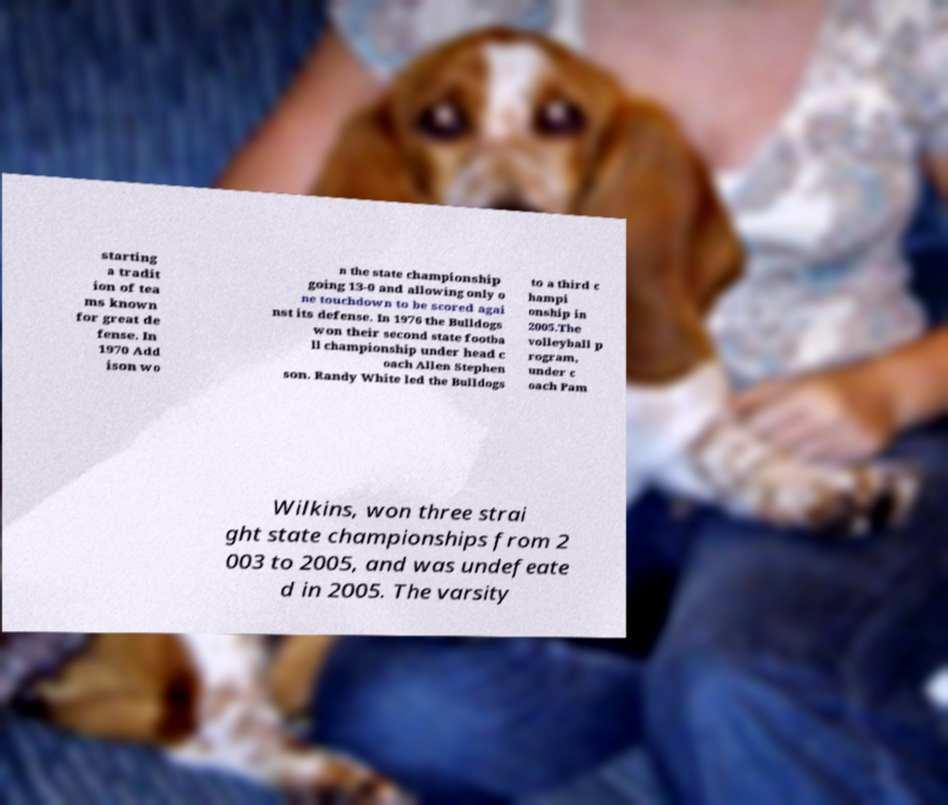Could you extract and type out the text from this image? starting a tradit ion of tea ms known for great de fense. In 1970 Add ison wo n the state championship going 13-0 and allowing only o ne touchdown to be scored agai nst its defense. In 1976 the Bulldogs won their second state footba ll championship under head c oach Allen Stephen son. Randy White led the Bulldogs to a third c hampi onship in 2005.The volleyball p rogram, under c oach Pam Wilkins, won three strai ght state championships from 2 003 to 2005, and was undefeate d in 2005. The varsity 